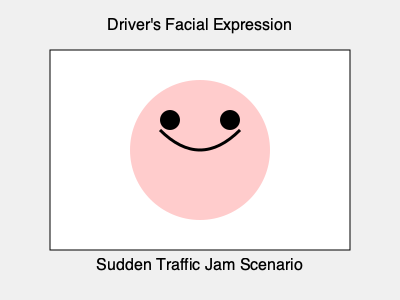Based on the driver's facial expression depicted in the image, what is the most likely emotional state of the driver encountering a sudden traffic jam, and how might this affect their driving behavior? 1. Facial features analysis:
   - The curved upward line represents a smile
   - Wide open eyes (large circles) suggest alertness or surprise
   - Overall relaxed facial muscles (smooth circular face shape)

2. Contextual information:
   - The scenario involves a sudden traffic jam, which is typically an unexpected and potentially frustrating situation

3. Emotional state interpretation:
   - The smile suggests a positive or neutral emotion
   - Wide eyes indicate surprise or heightened awareness
   - The combination points to a state of mild amusement or ironic acceptance

4. Behavioral implications:
   - Positive emotional state may lead to more patient and adaptive driving behavior
   - Heightened awareness could result in increased vigilance and safer driving
   - Acceptance of the situation might reduce aggressive responses or risky maneuvers

5. Conclusion:
   The driver appears to be in a state of amused surprise or ironic acceptance, which is likely to result in calm, patient driving behavior with increased awareness of surroundings.
Answer: Amused surprise; likely calm and vigilant driving 